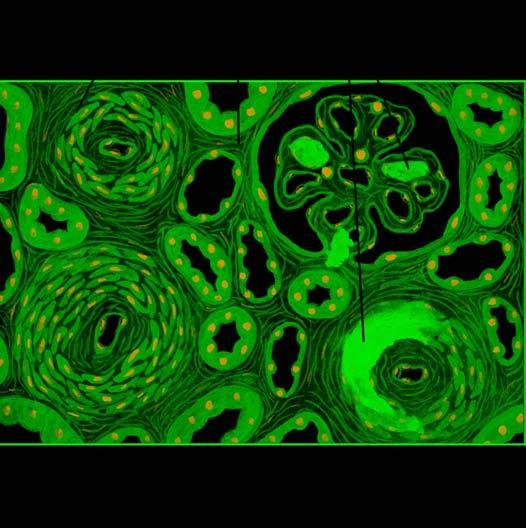re the vascular changes necrotising arteriolitis and hyperplastic intimal sclerosis or onion-skin proliferation?
Answer the question using a single word or phrase. Yes 